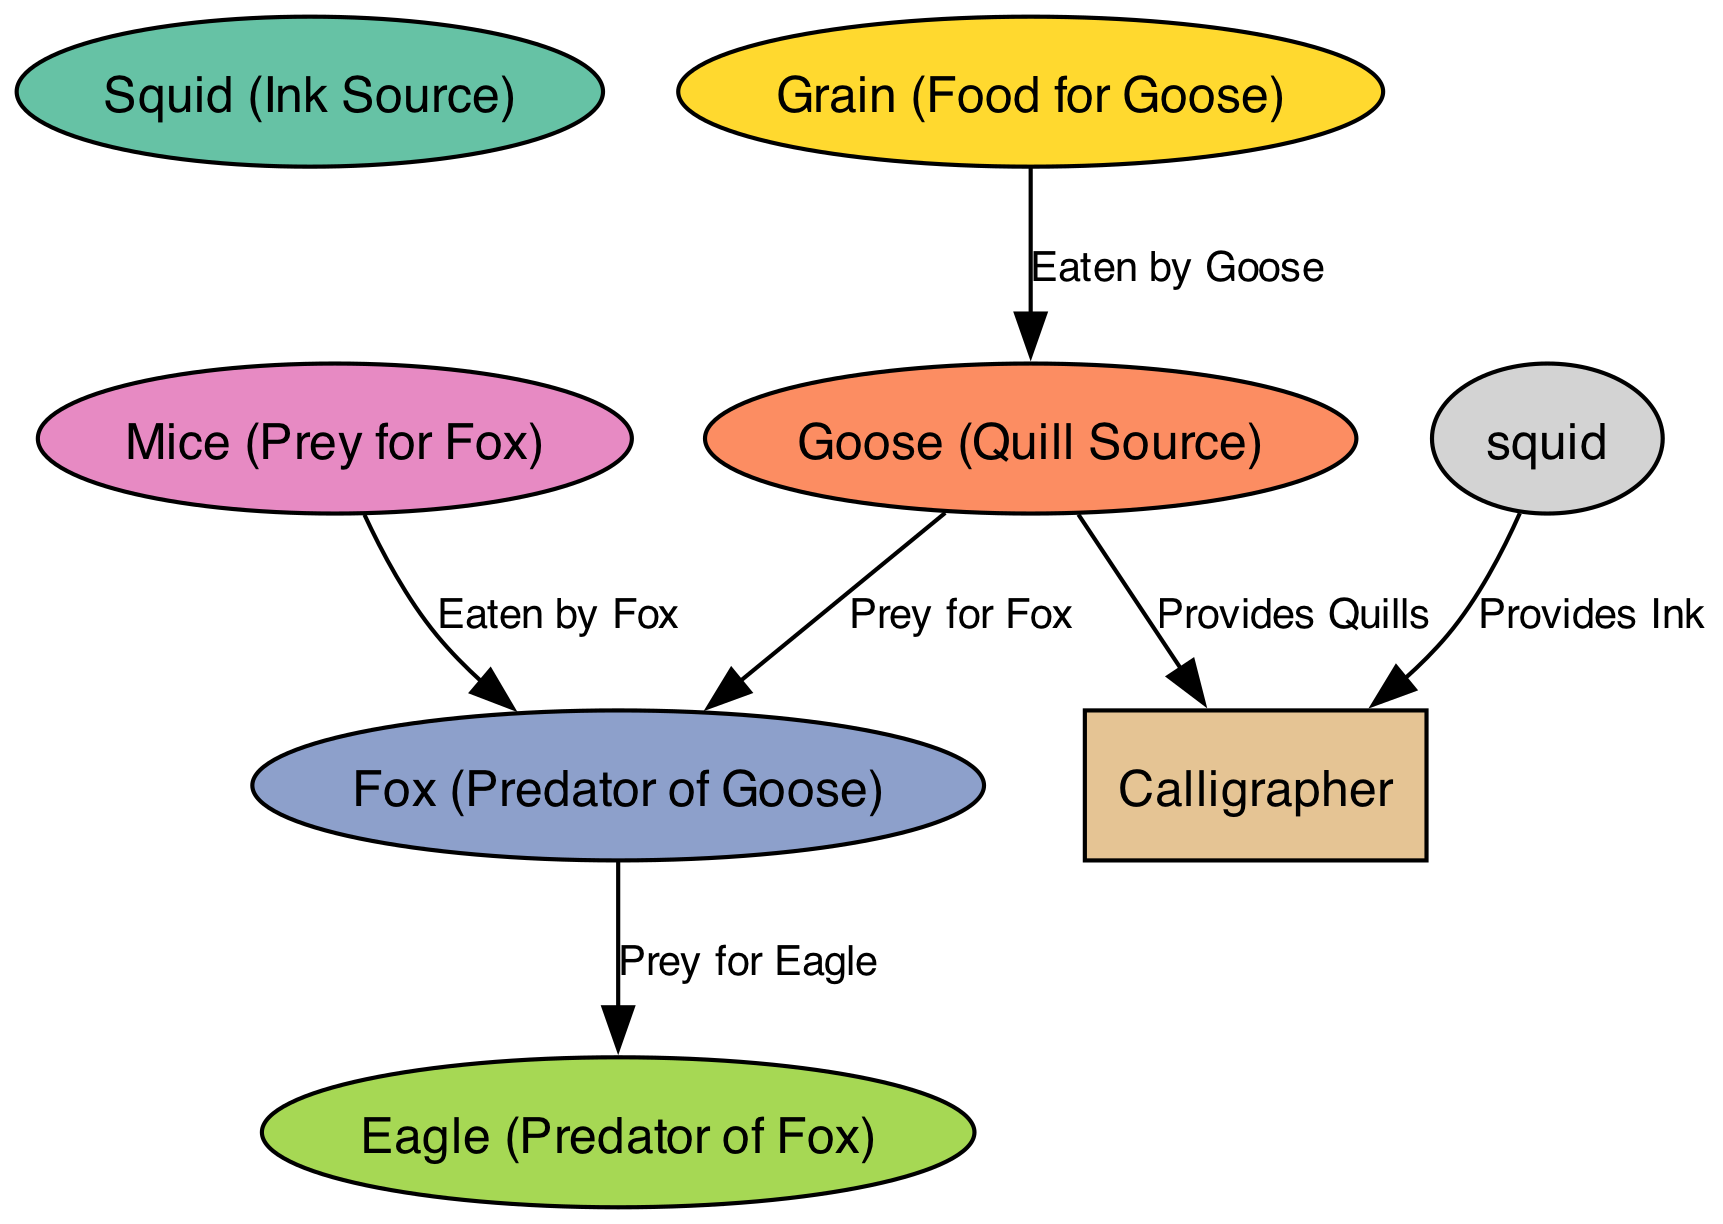What is the final consumer in this food chain? The final consumer at the top of the food chain, according to the diagram, is the Eagle. It is shown as the predator of the Fox, indicating its position as the top predator in this food chain context.
Answer: Eagle How many nodes are depicted in the diagram? The diagram includes a total of six nodes: Grain, Goose, Fox, Mice, Eagle, and Squid (as the ink source), which totals to six distinct entities.
Answer: 6 What does the Goose eat? According to the diagram, the Goose eats Grain, which is explicitly connected by the edge labeled "Eaten by Goose." This shows the direct dietary relationship in the food chain.
Answer: Grain Which animal is prey for the Fox? The diagram clearly indicates that the Goose is prey for the Fox, demonstrated by the edge labeled "Prey for Fox" connecting the two nodes.
Answer: Goose What provides the Calligrapher with ink? The diagram states that the Squid (Ink Source) provides ink to the Calligrapher. This relationship is described with the edge labeled "Provides Ink."
Answer: Squid Which animal preys on both Mice and Goose? By tracing the diagram, we see that the Fox preys on both Goose and Mice, as indicated by the connections labeled "Prey for Fox" (with Goose) and "Eaten by Fox" (with Mice).
Answer: Fox What role does Grain play in the food chain? The role of Grain in the food chain is foundational, as it provides food for the Goose, establishing a base for this specific food chain. This is captured by the edge labeled "Eaten by Goose."
Answer: Food for Goose How many edges connect the Goose to other nodes? The Goose connects to two nodes through edges: one to the Grain (it eats the Grain) and one to the Fox (it is prey for the Fox), which totals to two edges.
Answer: 2 Which predator is at the top of the food chain? The Eagle is identified as the top predator in the food chain, preying on the Fox, as shown by the edge labeled "Prey for Eagle." This denotes its apex position in this ecological framework.
Answer: Eagle 